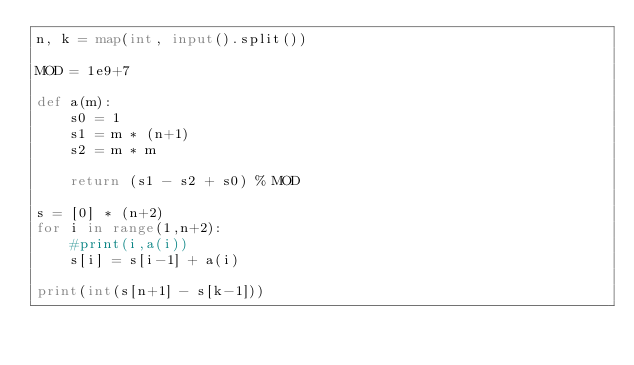Convert code to text. <code><loc_0><loc_0><loc_500><loc_500><_Python_>n, k = map(int, input().split())

MOD = 1e9+7

def a(m):
    s0 = 1
    s1 = m * (n+1)
    s2 = m * m
    
    return (s1 - s2 + s0) % MOD

s = [0] * (n+2)
for i in range(1,n+2):
    #print(i,a(i))
    s[i] = s[i-1] + a(i)

print(int(s[n+1] - s[k-1]))</code> 